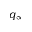<formula> <loc_0><loc_0><loc_500><loc_500>q _ { \infty }</formula> 